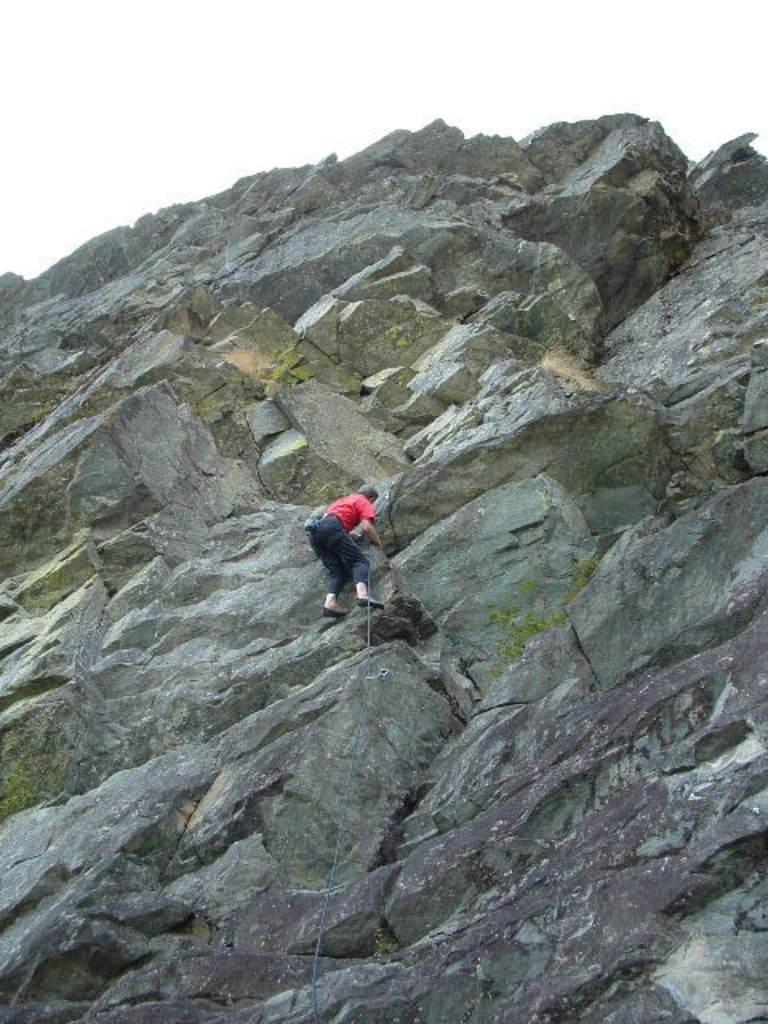What is the main activity being performed in the image? There is a person climbing a rock in the image. Can you describe the clothing worn by the person in the image? The person is wearing a dress with red and black colors. What can be seen in the background of the image? The sky in the background is white. How many frogs are visible in the image? There are no frogs present in the image. What type of writing can be seen on the rock being climbed? There is no writing visible on the rock in the image. 